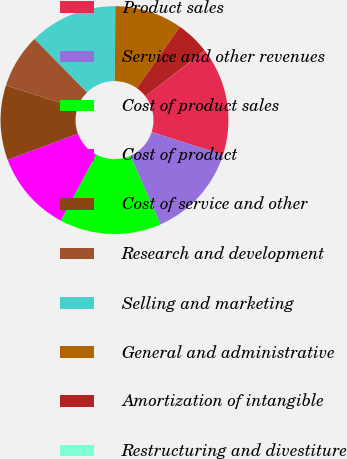<chart> <loc_0><loc_0><loc_500><loc_500><pie_chart><fcel>Product sales<fcel>Service and other revenues<fcel>Cost of product sales<fcel>Cost of product<fcel>Cost of service and other<fcel>Research and development<fcel>Selling and marketing<fcel>General and administrative<fcel>Amortization of intangible<fcel>Restructuring and divestiture<nl><fcel>15.38%<fcel>13.46%<fcel>14.42%<fcel>11.54%<fcel>10.58%<fcel>7.69%<fcel>12.5%<fcel>9.62%<fcel>4.81%<fcel>0.01%<nl></chart> 